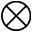Convert formula to latex. <formula><loc_0><loc_0><loc_500><loc_500>\otimes</formula> 